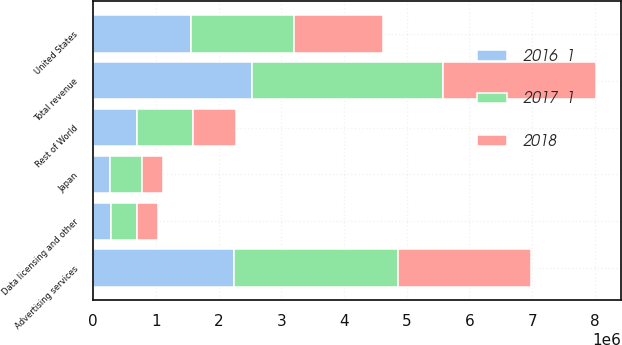Convert chart. <chart><loc_0><loc_0><loc_500><loc_500><stacked_bar_chart><ecel><fcel>Advertising services<fcel>Data licensing and other<fcel>Total revenue<fcel>United States<fcel>Japan<fcel>Rest of World<nl><fcel>2017  1<fcel>2.6174e+06<fcel>424962<fcel>3.04236e+06<fcel>1.64226e+06<fcel>507970<fcel>892130<nl><fcel>2018<fcel>2.10999e+06<fcel>333312<fcel>2.4433e+06<fcel>1.41361e+06<fcel>343741<fcel>685944<nl><fcel>2016  1<fcel>2.24805e+06<fcel>281567<fcel>2.52962e+06<fcel>1.56478e+06<fcel>268496<fcel>696347<nl></chart> 